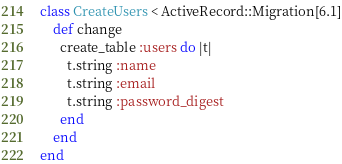Convert code to text. <code><loc_0><loc_0><loc_500><loc_500><_Ruby_>class CreateUsers < ActiveRecord::Migration[6.1]
    def change
      create_table :users do |t|
        t.string :name
        t.string :email
        t.string :password_digest
      end
    end
end
</code> 